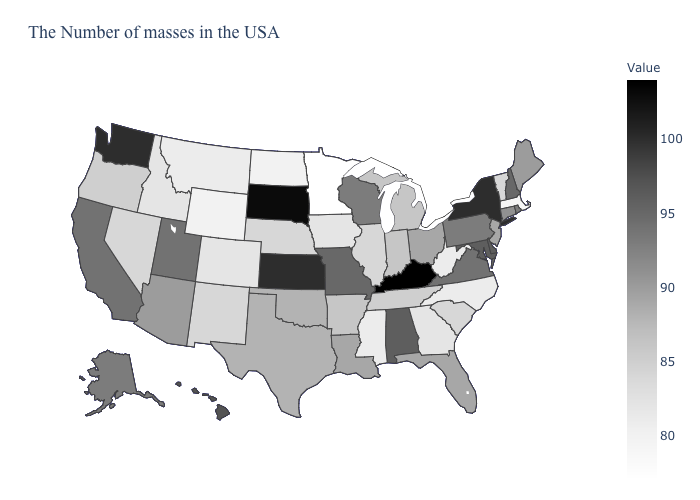Among the states that border Kentucky , which have the lowest value?
Keep it brief. West Virginia. Among the states that border Connecticut , which have the lowest value?
Give a very brief answer. Massachusetts. Which states hav the highest value in the MidWest?
Be succinct. South Dakota. Among the states that border Nevada , which have the highest value?
Be succinct. Utah, California. Does Illinois have a higher value than North Carolina?
Answer briefly. Yes. Which states have the lowest value in the South?
Be succinct. North Carolina, West Virginia, Mississippi. Among the states that border Delaware , which have the highest value?
Answer briefly. Maryland. 